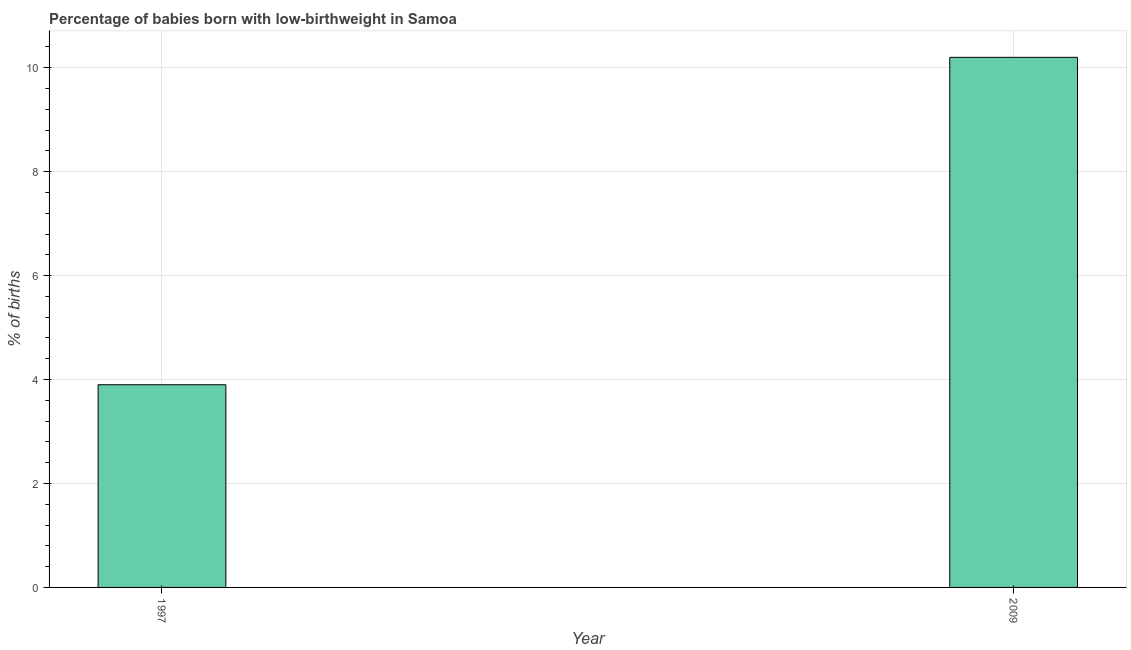Does the graph contain grids?
Make the answer very short. Yes. What is the title of the graph?
Give a very brief answer. Percentage of babies born with low-birthweight in Samoa. What is the label or title of the Y-axis?
Your answer should be compact. % of births. What is the percentage of babies who were born with low-birthweight in 2009?
Provide a short and direct response. 10.2. In which year was the percentage of babies who were born with low-birthweight maximum?
Ensure brevity in your answer.  2009. In which year was the percentage of babies who were born with low-birthweight minimum?
Offer a terse response. 1997. What is the difference between the percentage of babies who were born with low-birthweight in 1997 and 2009?
Your answer should be very brief. -6.3. What is the average percentage of babies who were born with low-birthweight per year?
Provide a short and direct response. 7.05. What is the median percentage of babies who were born with low-birthweight?
Make the answer very short. 7.05. Do a majority of the years between 2009 and 1997 (inclusive) have percentage of babies who were born with low-birthweight greater than 10 %?
Ensure brevity in your answer.  No. What is the ratio of the percentage of babies who were born with low-birthweight in 1997 to that in 2009?
Give a very brief answer. 0.38. Is the percentage of babies who were born with low-birthweight in 1997 less than that in 2009?
Make the answer very short. Yes. In how many years, is the percentage of babies who were born with low-birthweight greater than the average percentage of babies who were born with low-birthweight taken over all years?
Your response must be concise. 1. How many bars are there?
Keep it short and to the point. 2. How many years are there in the graph?
Provide a short and direct response. 2. What is the difference between two consecutive major ticks on the Y-axis?
Your answer should be very brief. 2. What is the difference between the % of births in 1997 and 2009?
Provide a short and direct response. -6.3. What is the ratio of the % of births in 1997 to that in 2009?
Keep it short and to the point. 0.38. 